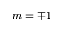Convert formula to latex. <formula><loc_0><loc_0><loc_500><loc_500>m = \mp 1</formula> 